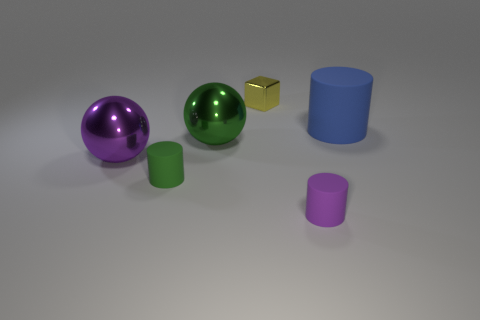There is a green metallic ball; does it have the same size as the rubber cylinder that is behind the green cylinder? While it's difficult to determine the exact size without measurements, the green metallic ball appears slightly larger than the purple rubber cylinder behind it, judging by their relative sizes in the image. 